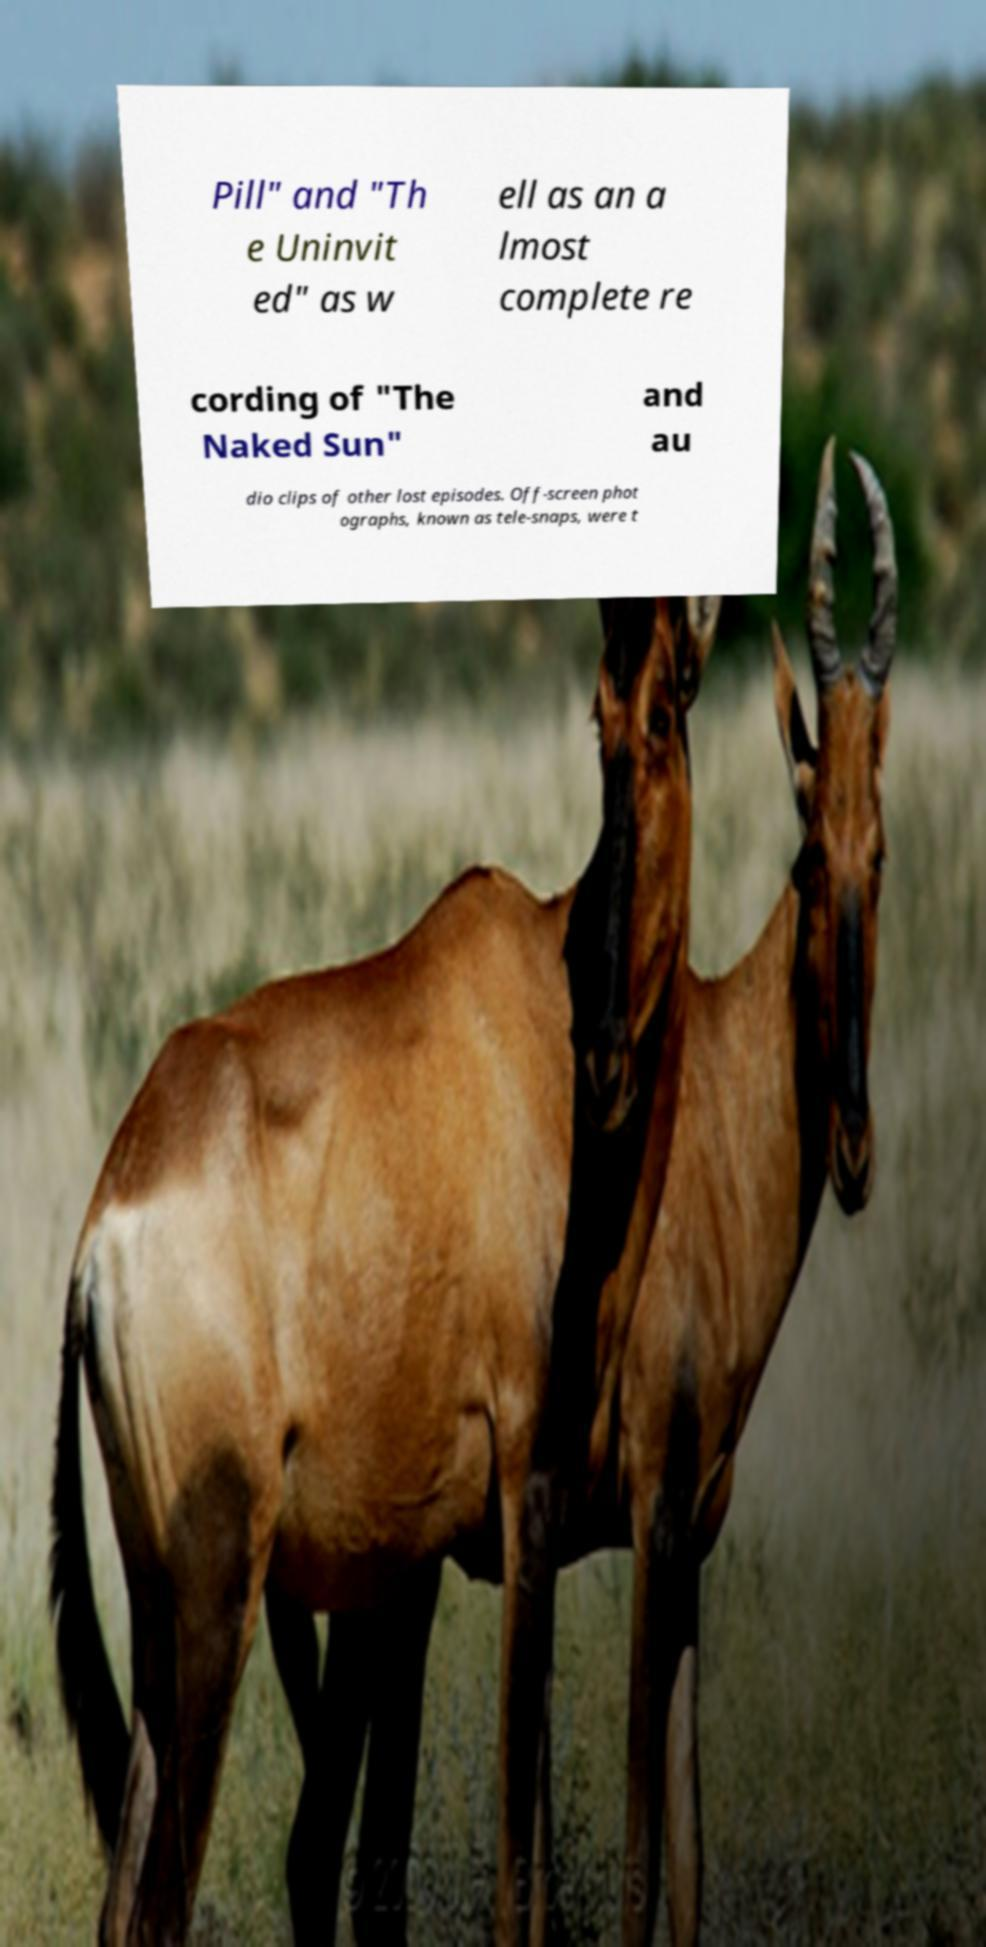Can you accurately transcribe the text from the provided image for me? Pill" and "Th e Uninvit ed" as w ell as an a lmost complete re cording of "The Naked Sun" and au dio clips of other lost episodes. Off-screen phot ographs, known as tele-snaps, were t 